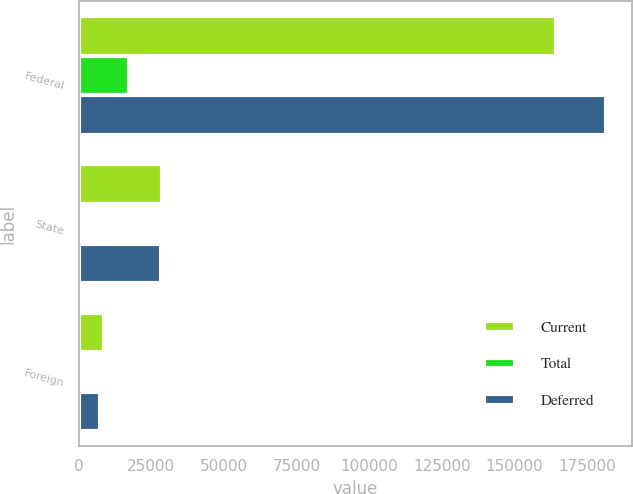Convert chart. <chart><loc_0><loc_0><loc_500><loc_500><stacked_bar_chart><ecel><fcel>Federal<fcel>State<fcel>Foreign<nl><fcel>Current<fcel>164125<fcel>28669<fcel>8683<nl><fcel>Total<fcel>17343<fcel>244<fcel>1424<nl><fcel>Deferred<fcel>181468<fcel>28425<fcel>7259<nl></chart> 